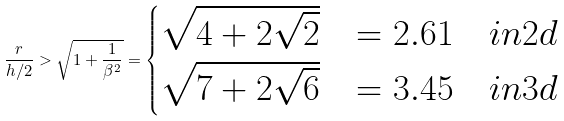Convert formula to latex. <formula><loc_0><loc_0><loc_500><loc_500>\frac { r } { h / 2 } > \sqrt { 1 + \frac { 1 } { \beta ^ { 2 } } } = \begin{cases} \sqrt { 4 + 2 \sqrt { 2 } } & = 2 . 6 1 \quad i n 2 d \\ \sqrt { 7 + 2 \sqrt { 6 } } & = 3 . 4 5 \quad i n 3 d \end{cases}</formula> 